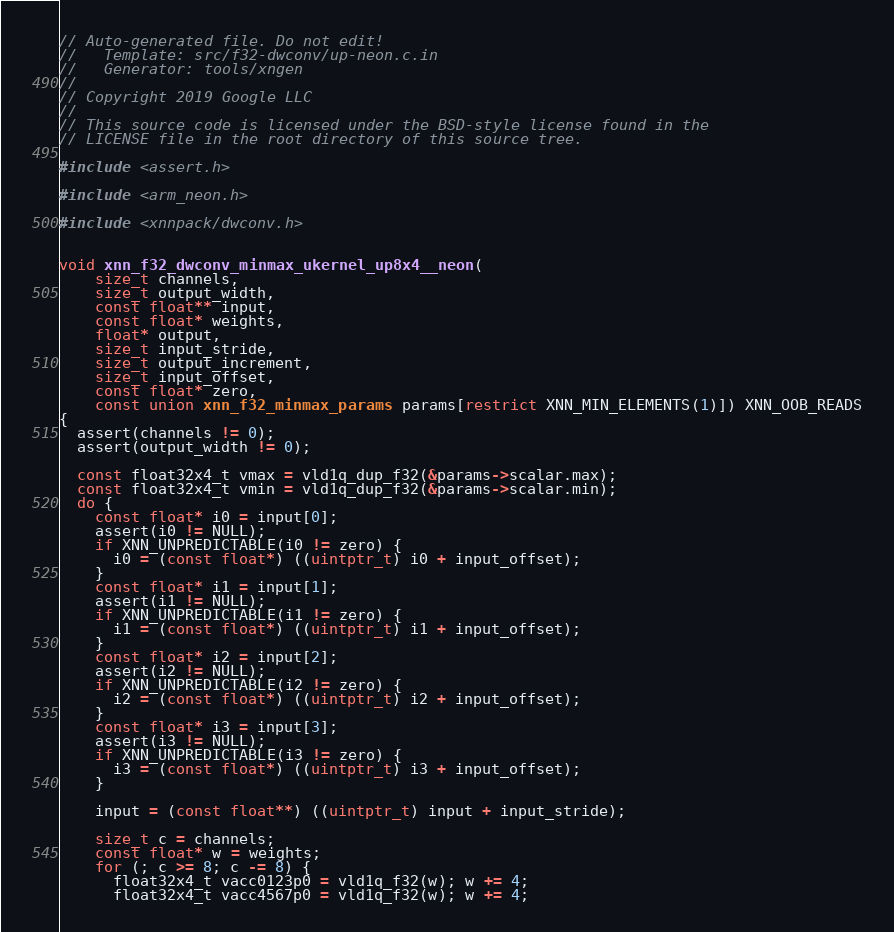<code> <loc_0><loc_0><loc_500><loc_500><_C_>// Auto-generated file. Do not edit!
//   Template: src/f32-dwconv/up-neon.c.in
//   Generator: tools/xngen
//
// Copyright 2019 Google LLC
//
// This source code is licensed under the BSD-style license found in the
// LICENSE file in the root directory of this source tree.

#include <assert.h>

#include <arm_neon.h>

#include <xnnpack/dwconv.h>


void xnn_f32_dwconv_minmax_ukernel_up8x4__neon(
    size_t channels,
    size_t output_width,
    const float** input,
    const float* weights,
    float* output,
    size_t input_stride,
    size_t output_increment,
    size_t input_offset,
    const float* zero,
    const union xnn_f32_minmax_params params[restrict XNN_MIN_ELEMENTS(1)]) XNN_OOB_READS
{
  assert(channels != 0);
  assert(output_width != 0);

  const float32x4_t vmax = vld1q_dup_f32(&params->scalar.max);
  const float32x4_t vmin = vld1q_dup_f32(&params->scalar.min);
  do {
    const float* i0 = input[0];
    assert(i0 != NULL);
    if XNN_UNPREDICTABLE(i0 != zero) {
      i0 = (const float*) ((uintptr_t) i0 + input_offset);
    }
    const float* i1 = input[1];
    assert(i1 != NULL);
    if XNN_UNPREDICTABLE(i1 != zero) {
      i1 = (const float*) ((uintptr_t) i1 + input_offset);
    }
    const float* i2 = input[2];
    assert(i2 != NULL);
    if XNN_UNPREDICTABLE(i2 != zero) {
      i2 = (const float*) ((uintptr_t) i2 + input_offset);
    }
    const float* i3 = input[3];
    assert(i3 != NULL);
    if XNN_UNPREDICTABLE(i3 != zero) {
      i3 = (const float*) ((uintptr_t) i3 + input_offset);
    }

    input = (const float**) ((uintptr_t) input + input_stride);

    size_t c = channels;
    const float* w = weights;
    for (; c >= 8; c -= 8) {
      float32x4_t vacc0123p0 = vld1q_f32(w); w += 4;
      float32x4_t vacc4567p0 = vld1q_f32(w); w += 4;

</code> 